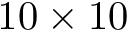<formula> <loc_0><loc_0><loc_500><loc_500>1 0 \times 1 0</formula> 